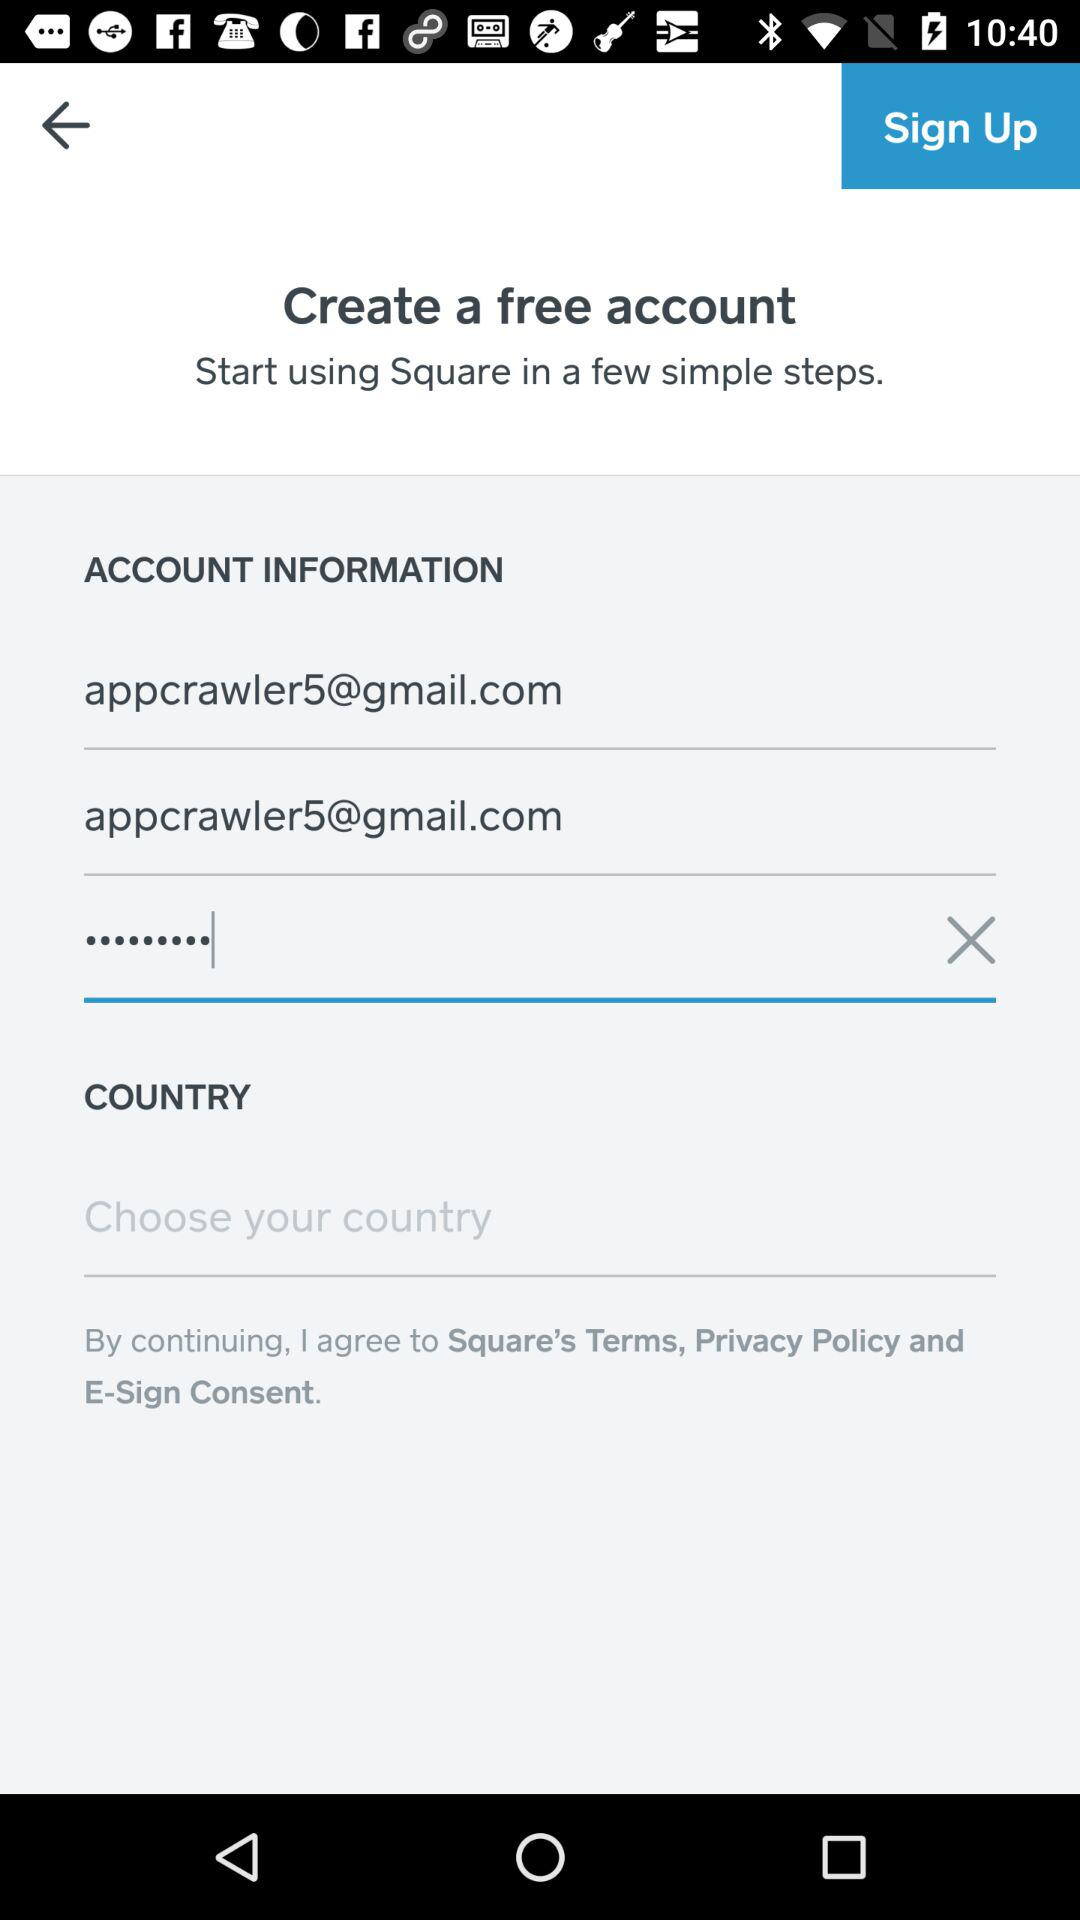How many text inputs are there with an email address in them? 2 